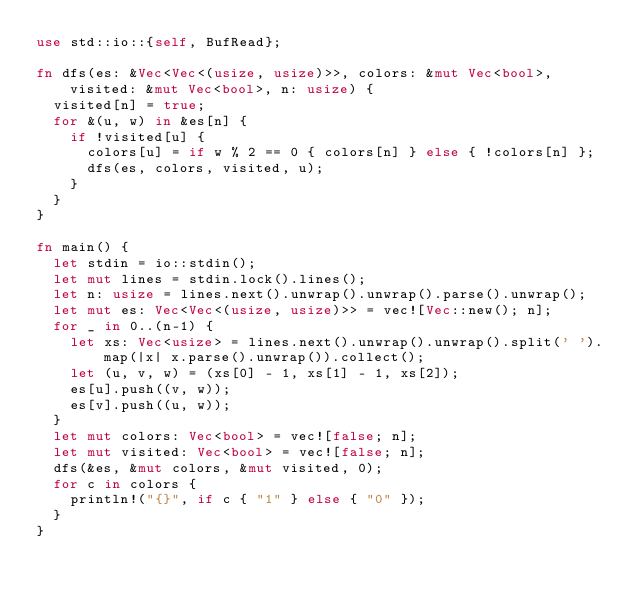Convert code to text. <code><loc_0><loc_0><loc_500><loc_500><_Rust_>use std::io::{self, BufRead};

fn dfs(es: &Vec<Vec<(usize, usize)>>, colors: &mut Vec<bool>, visited: &mut Vec<bool>, n: usize) {
  visited[n] = true;
  for &(u, w) in &es[n] {
    if !visited[u] {
      colors[u] = if w % 2 == 0 { colors[n] } else { !colors[n] };
      dfs(es, colors, visited, u);
    }
  }
}

fn main() {
  let stdin = io::stdin();
  let mut lines = stdin.lock().lines();
  let n: usize = lines.next().unwrap().unwrap().parse().unwrap();
  let mut es: Vec<Vec<(usize, usize)>> = vec![Vec::new(); n];
  for _ in 0..(n-1) {
    let xs: Vec<usize> = lines.next().unwrap().unwrap().split(' ').map(|x| x.parse().unwrap()).collect();
    let (u, v, w) = (xs[0] - 1, xs[1] - 1, xs[2]);
    es[u].push((v, w));
    es[v].push((u, w));
  }
  let mut colors: Vec<bool> = vec![false; n];
  let mut visited: Vec<bool> = vec![false; n];
  dfs(&es, &mut colors, &mut visited, 0);
  for c in colors {
    println!("{}", if c { "1" } else { "0" });
  }
}</code> 